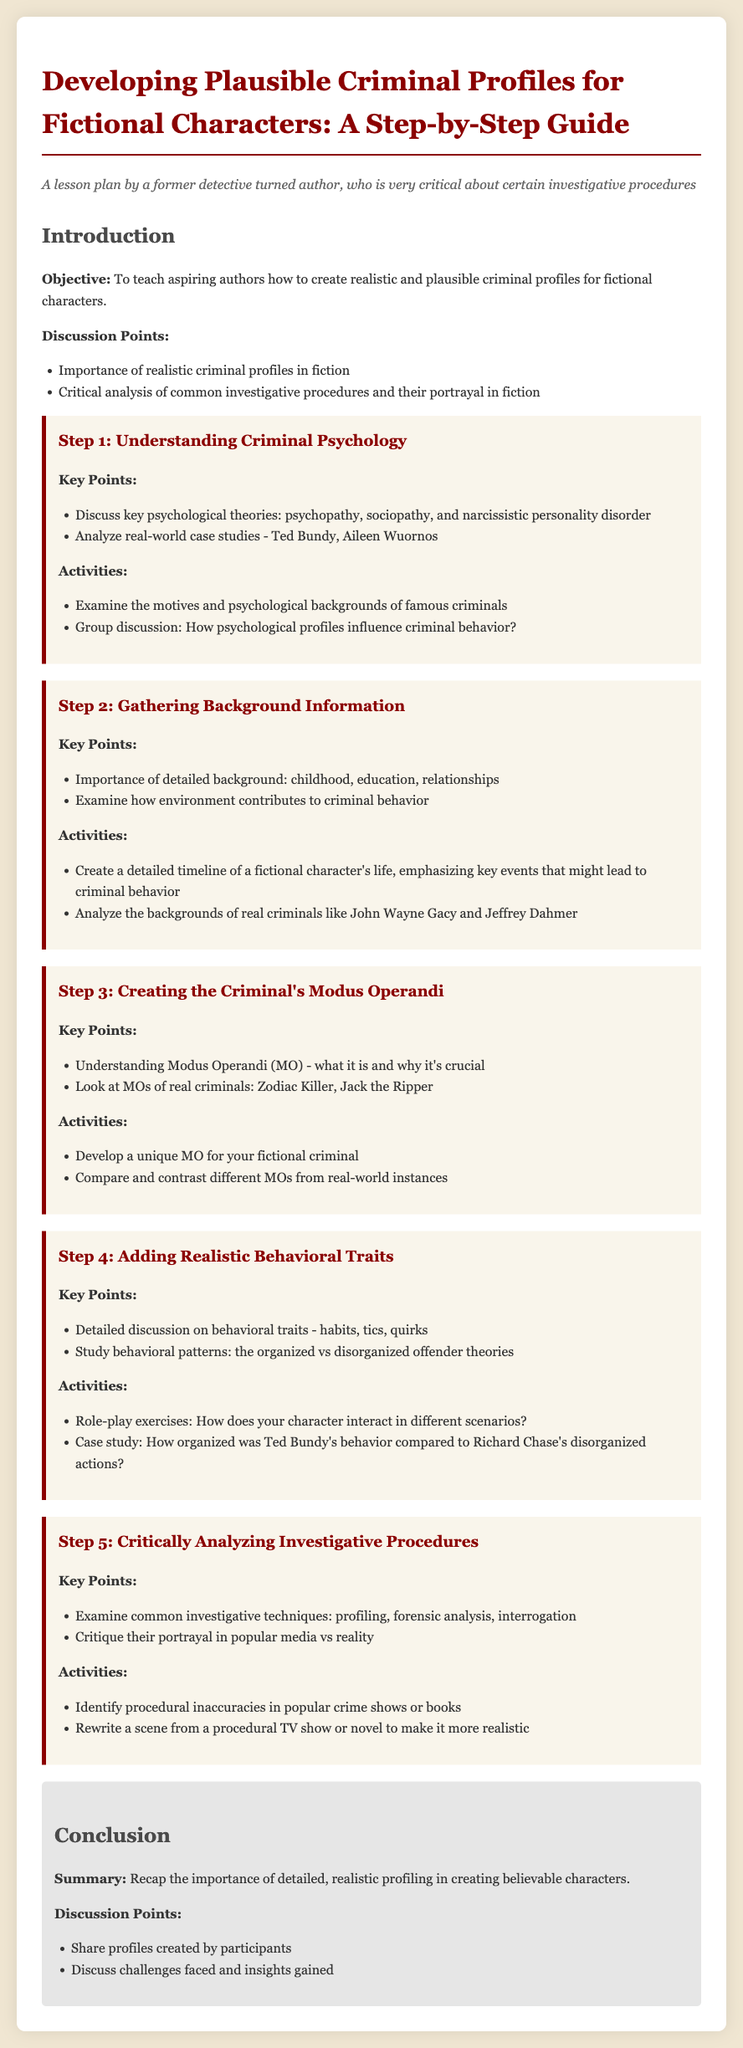What is the primary objective of the lesson plan? The objective is stated clearly as to teach aspiring authors how to create realistic and plausible criminal profiles for fictional characters.
Answer: To teach aspiring authors how to create realistic and plausible criminal profiles for fictional characters Name one psychological theory discussed in Step 1. Step 1 emphasizes understanding criminal psychology and mentions key psychological theories.
Answer: Psychopathy Which real-world criminal is analyzed in Step 2? Step 2 includes the analysis of backgrounds in criminal behavior and mentions specific criminals.
Answer: John Wayne Gacy What is meant by Modus Operandi as described in Step 3? Step 3 defines Modus Operandi and explains its significance in character profiling.
Answer: What it is and why it's crucial In Step 4, what types of offenders are compared? Step 4 examines behavioral patterns and the theories surrounding them.
Answer: Organized vs disorganized offender theories What activity is suggested in Step 5 related to popular crime media? Step 5 involves critiquing investigative procedures, including an activity regarding crime shows.
Answer: Identify procedural inaccuracies How does the lesson plan conclude? The conclusion summarizes the importance of detailed profiling and invites participants to share their work.
Answer: Recap the importance of detailed, realistic profiling in creating believable characters What is one of the critical analysis points discussed in the lesson plan? The lesson plan encourages critical evaluation of common investigative techniques and their portrayal in media.
Answer: Profiling, forensic analysis, interrogation 